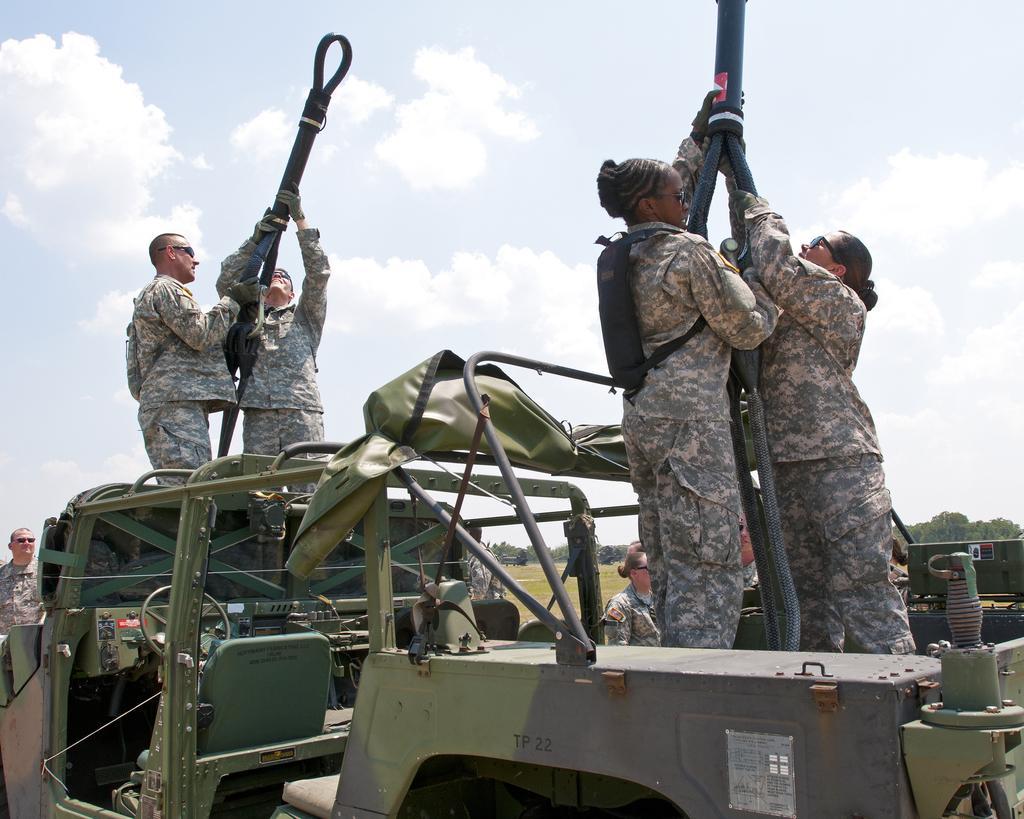In one or two sentences, can you explain what this image depicts? In this picture I can see there are two women standing in the jeep and they are holding a object in their hand at right side and there are two men standing at left side and they are also holding a object in their hand. I can see there are few people walking here and few are standing. There is grass on the floor, there are trees in the backdrop and the sky is clear. 